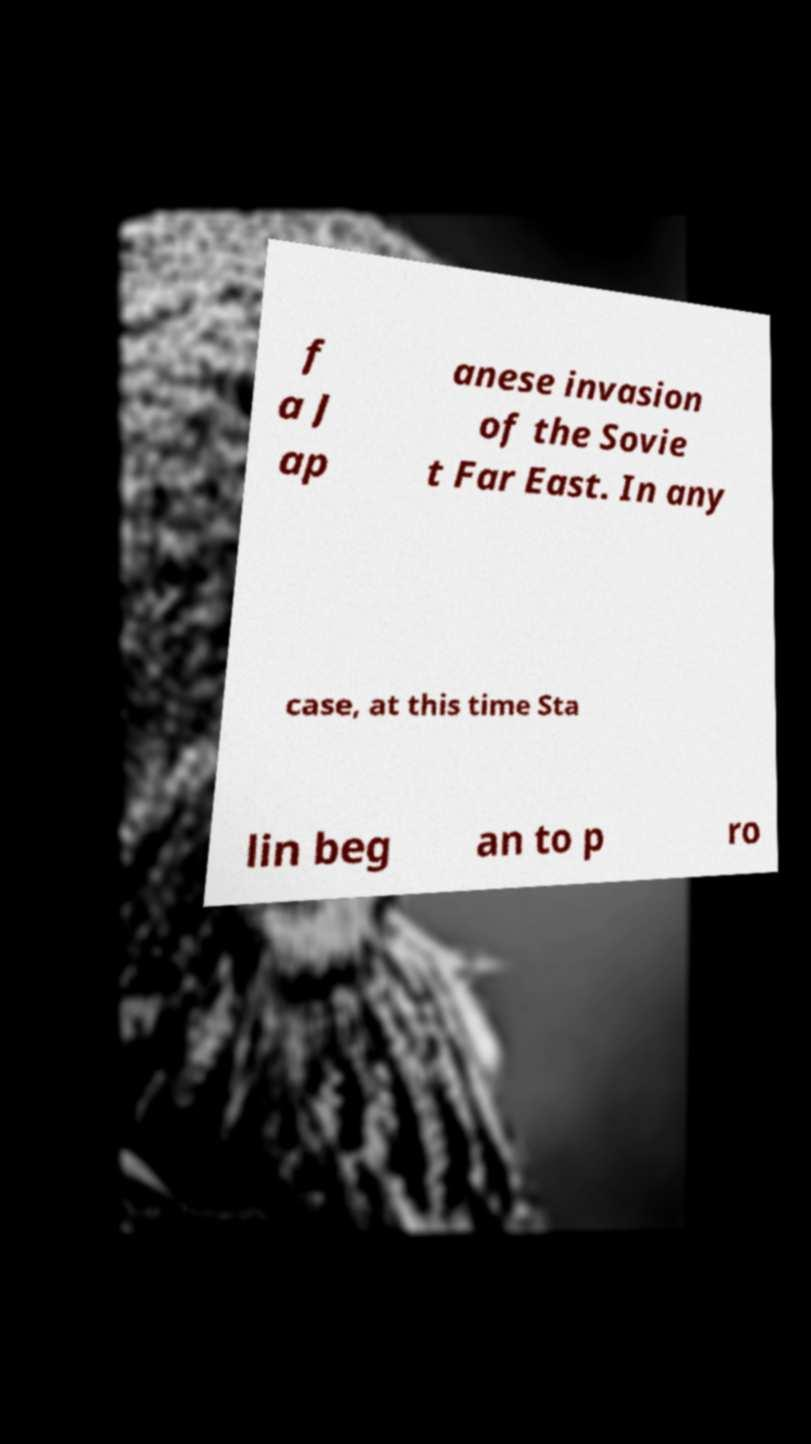Can you read and provide the text displayed in the image?This photo seems to have some interesting text. Can you extract and type it out for me? f a J ap anese invasion of the Sovie t Far East. In any case, at this time Sta lin beg an to p ro 